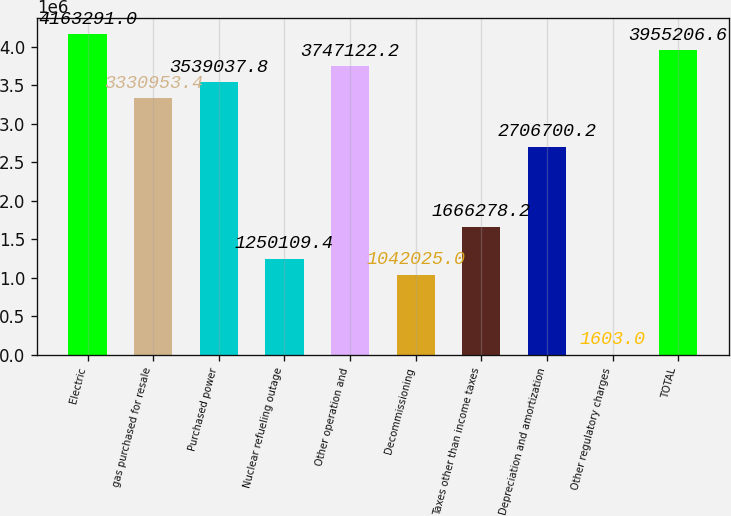Convert chart to OTSL. <chart><loc_0><loc_0><loc_500><loc_500><bar_chart><fcel>Electric<fcel>gas purchased for resale<fcel>Purchased power<fcel>Nuclear refueling outage<fcel>Other operation and<fcel>Decommissioning<fcel>Taxes other than income taxes<fcel>Depreciation and amortization<fcel>Other regulatory charges<fcel>TOTAL<nl><fcel>4.16329e+06<fcel>3.33095e+06<fcel>3.53904e+06<fcel>1.25011e+06<fcel>3.74712e+06<fcel>1.04202e+06<fcel>1.66628e+06<fcel>2.7067e+06<fcel>1603<fcel>3.95521e+06<nl></chart> 